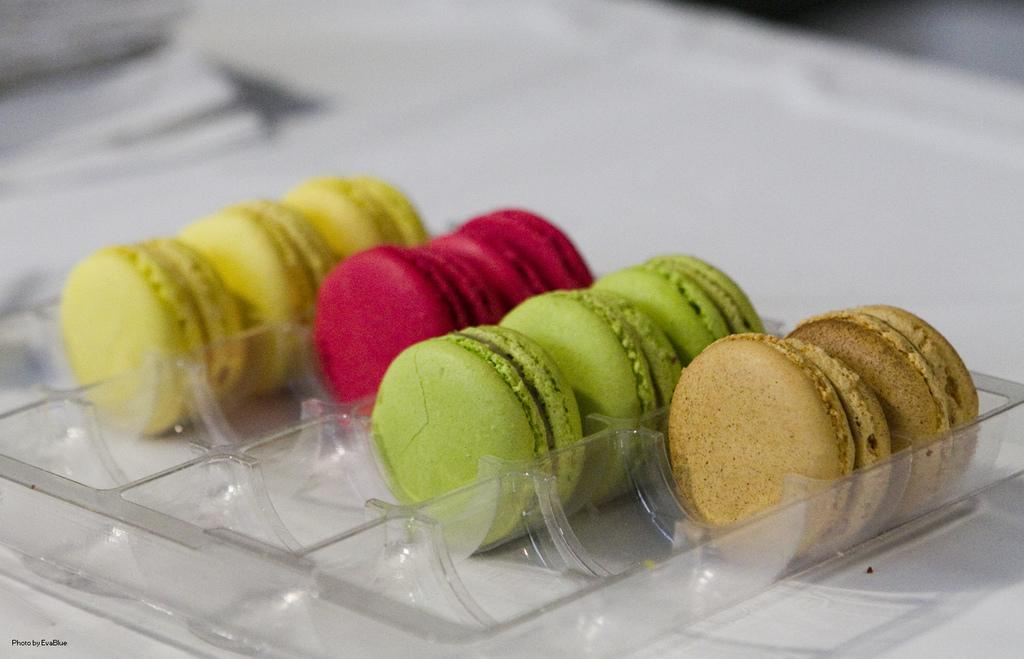What type of food can be seen in the image? There are cookies in the image. How are the cookies arranged or stored? The cookies are kept in a tray. What can be observed about the appearance of the cookies? The cookies are of different colors. Can you describe the background of the image? The background of the cookies is blurred. What type of soap is used to clean the tray in the image? There is no soap present in the image, and the tray is not being cleaned. Can you describe the coil that is wrapped around the cookies in the image? There is no coil present in the image; the cookies are simply arranged in a tray. 